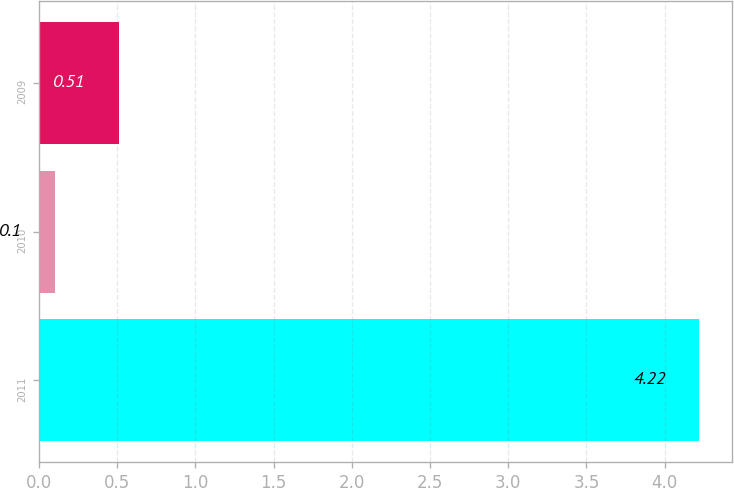Convert chart to OTSL. <chart><loc_0><loc_0><loc_500><loc_500><bar_chart><fcel>2011<fcel>2010<fcel>2009<nl><fcel>4.22<fcel>0.1<fcel>0.51<nl></chart> 